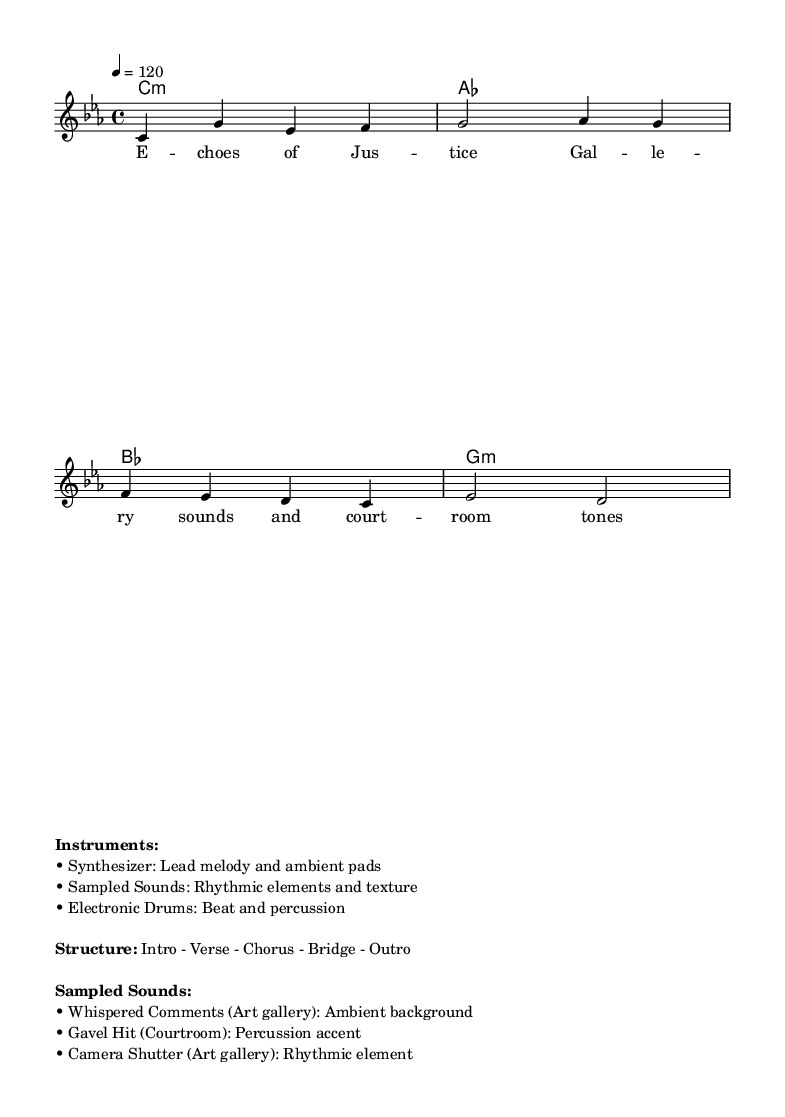What is the key signature of this music? The key signature is C minor, indicated by three flats in the key signature area.
Answer: C minor What is the time signature of this music? The time signature is 4/4, which can be found at the beginning of the score.
Answer: 4/4 What is the tempo marking of this music? The tempo marking indicates a speed of 120 beats per minute, which is noted in the tempo indication at the beginning.
Answer: 120 How many measures are in the melody? The melody consists of four measures, as counted from the beginning to the end of the melody section.
Answer: 4 What type of electronic instrument leads the melody? The lead melody is played by a synthesizer, as indicated in the instruments section.
Answer: Synthesizer Which sampled sound is used as a percussion accent? The gavel hit sampled from a courtroom is used as a percussion accent, confirming its role in the rhythmic structure.
Answer: Gavel Hit What is the structure of this piece? The structure is indicated as Intro - Verse - Chorus - Bridge - Outro, denoting the overall flow of the composition.
Answer: Intro - Verse - Chorus - Bridge - Outro 